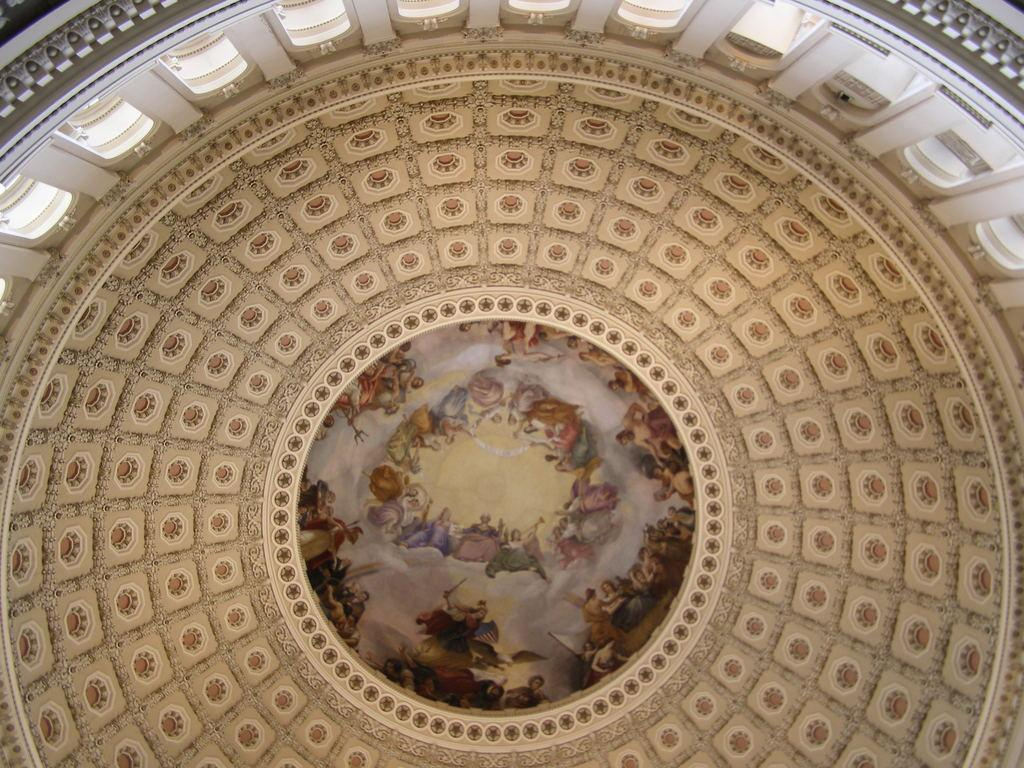What type of location is shown in the image? The image depicts the interior of a building. What can be seen in the middle of the image? There is a picture in the middle of the image. How many drawers are visible in the image? There is no mention of drawers in the provided facts, so we cannot determine the number of drawers in the image. 